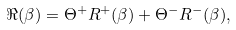<formula> <loc_0><loc_0><loc_500><loc_500>\Re ( \beta ) = \Theta ^ { + } R ^ { + } ( \beta ) + \Theta ^ { - } R ^ { - } ( \beta ) ,</formula> 